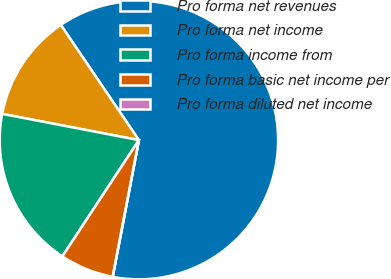Convert chart. <chart><loc_0><loc_0><loc_500><loc_500><pie_chart><fcel>Pro forma net revenues<fcel>Pro forma net income<fcel>Pro forma income from<fcel>Pro forma basic net income per<fcel>Pro forma diluted net income<nl><fcel>62.5%<fcel>12.5%<fcel>18.75%<fcel>6.25%<fcel>0.0%<nl></chart> 